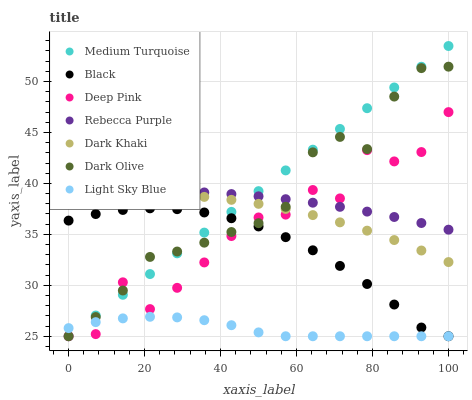Does Light Sky Blue have the minimum area under the curve?
Answer yes or no. Yes. Does Medium Turquoise have the maximum area under the curve?
Answer yes or no. Yes. Does Dark Olive have the minimum area under the curve?
Answer yes or no. No. Does Dark Olive have the maximum area under the curve?
Answer yes or no. No. Is Medium Turquoise the smoothest?
Answer yes or no. Yes. Is Deep Pink the roughest?
Answer yes or no. Yes. Is Dark Olive the smoothest?
Answer yes or no. No. Is Dark Olive the roughest?
Answer yes or no. No. Does Deep Pink have the lowest value?
Answer yes or no. Yes. Does Dark Khaki have the lowest value?
Answer yes or no. No. Does Medium Turquoise have the highest value?
Answer yes or no. Yes. Does Dark Olive have the highest value?
Answer yes or no. No. Is Dark Khaki less than Rebecca Purple?
Answer yes or no. Yes. Is Rebecca Purple greater than Black?
Answer yes or no. Yes. Does Light Sky Blue intersect Dark Olive?
Answer yes or no. Yes. Is Light Sky Blue less than Dark Olive?
Answer yes or no. No. Is Light Sky Blue greater than Dark Olive?
Answer yes or no. No. Does Dark Khaki intersect Rebecca Purple?
Answer yes or no. No. 